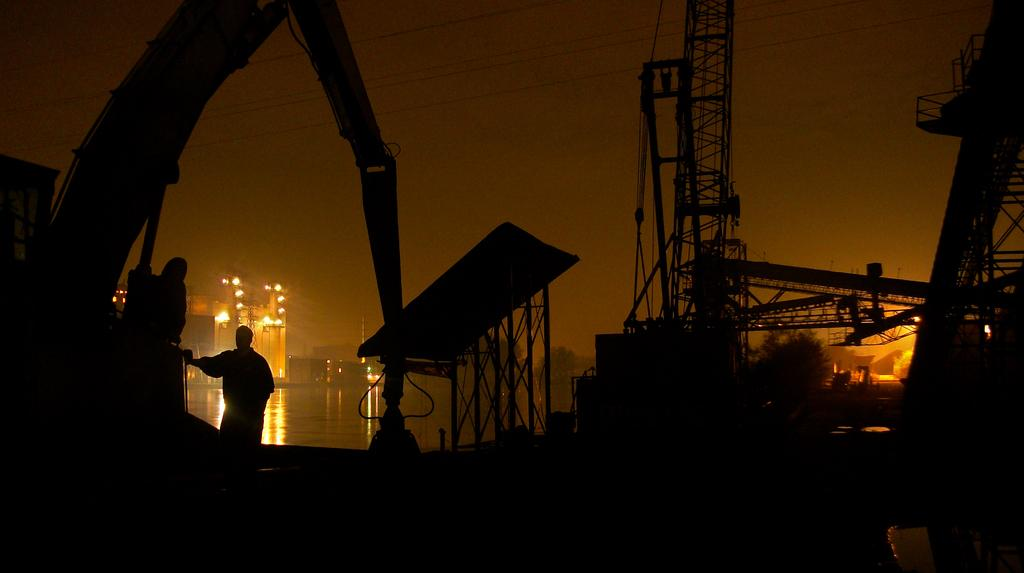What is the main subject of the image? There is a person in the image. What can be seen in the background of the image? Buildings, trees, and a blurry background are visible in the image. What is the condition of the water in the image? Water is visible in the image, but its condition is not specified. What type of artificial structures can be seen in the image? Cranes are present in the image. What other objects are present in the image? There are some unspecified objects in the image. How many jellyfish can be seen swimming in the water in the image? There are no jellyfish present in the image; it features a person, buildings, trees, and water. What is the temperature of the heat source in the image? There is no heat source present in the image. 